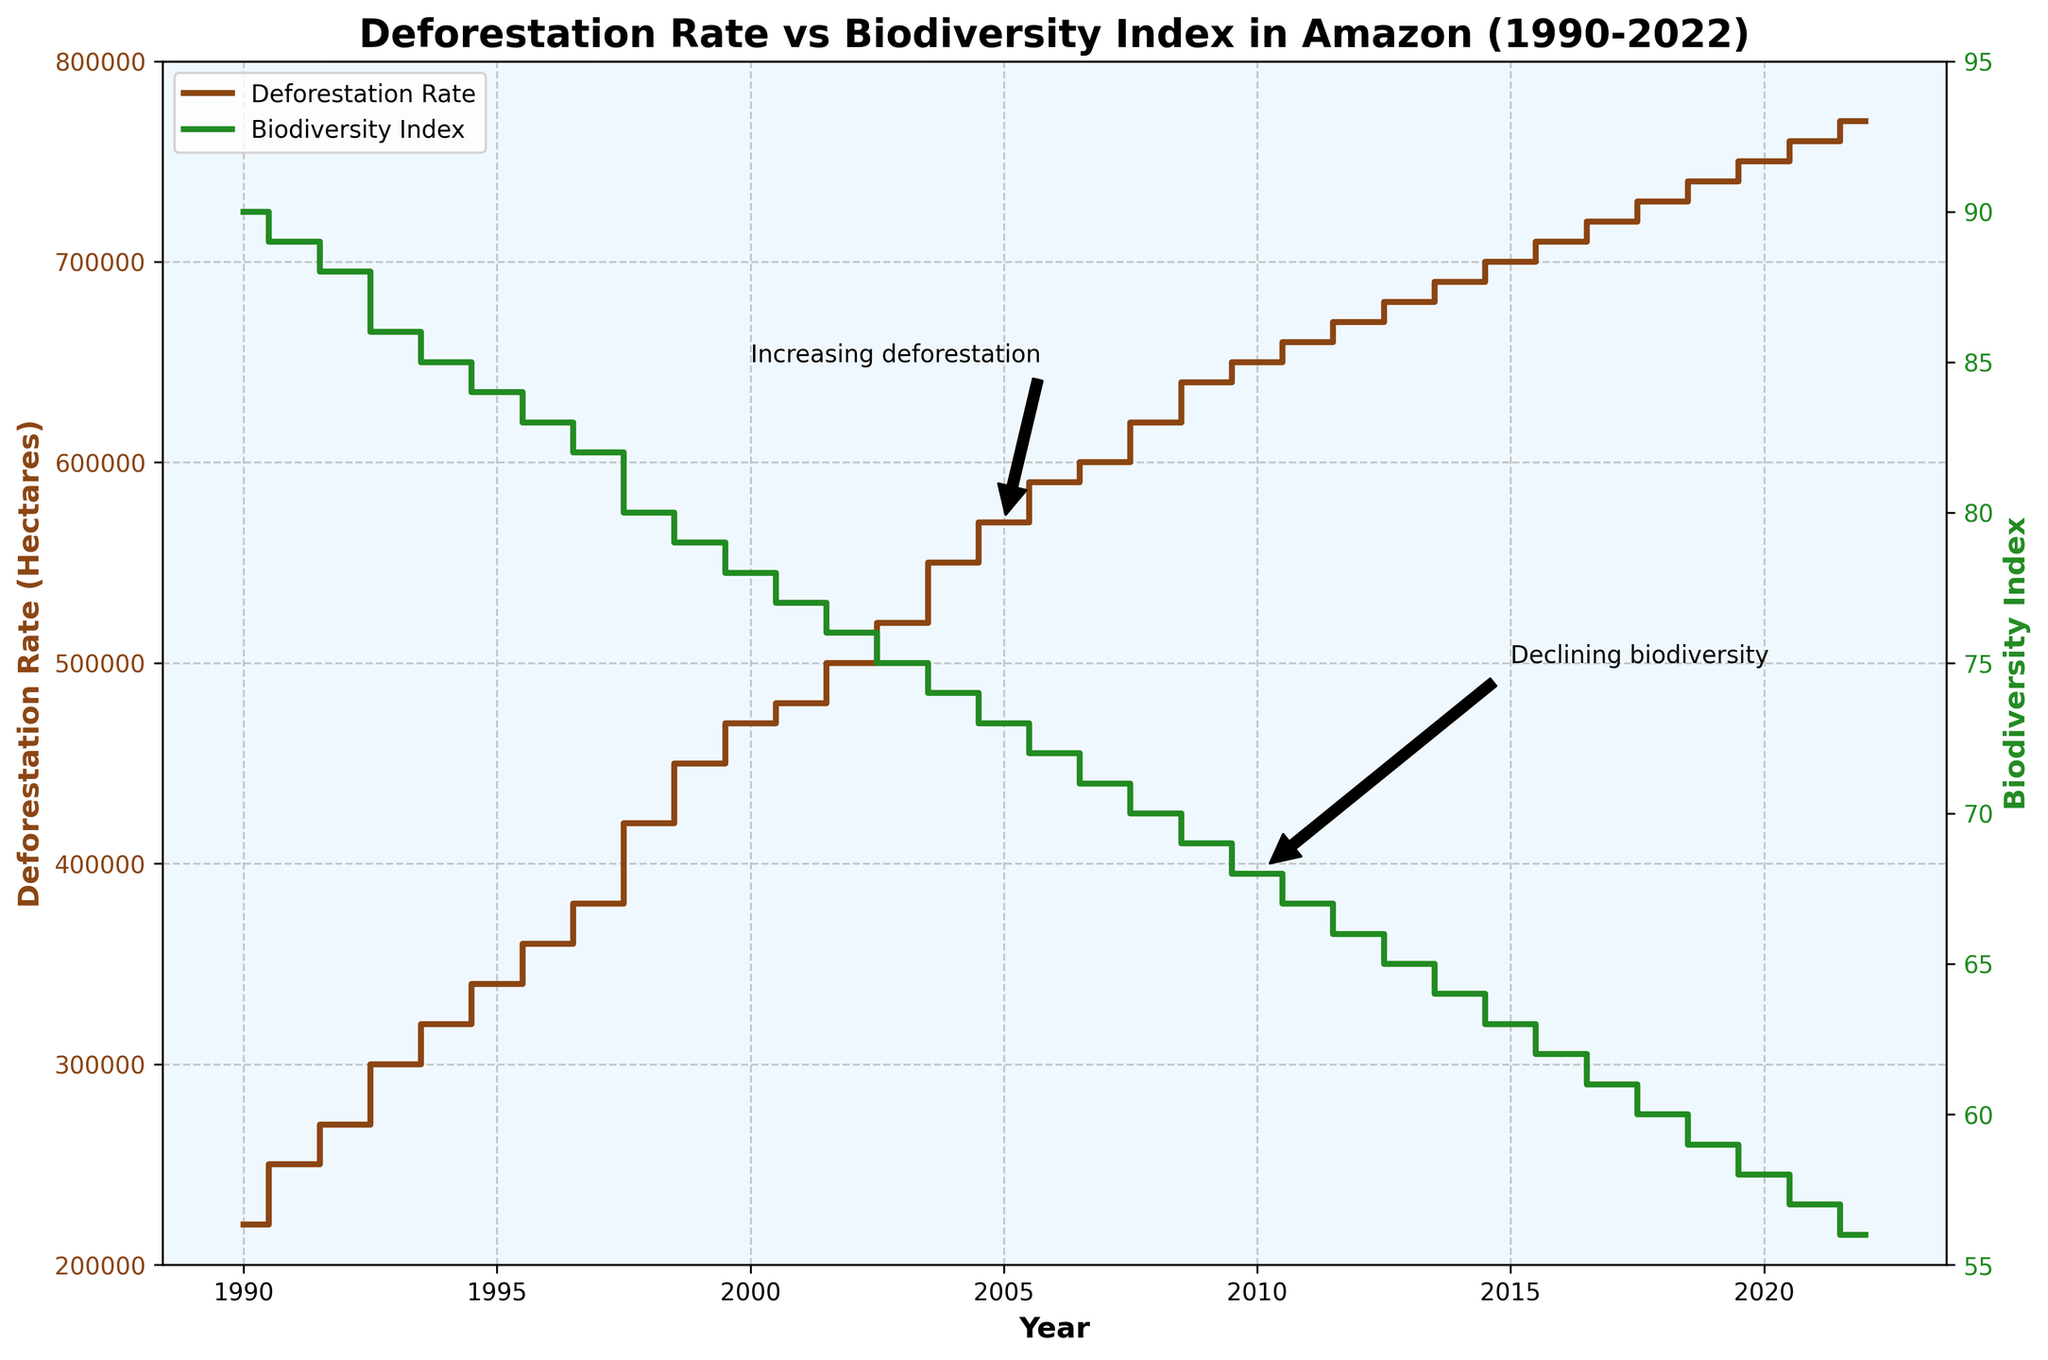what is the title of the figure? The title is displayed prominently at the top of the figure and provides a summary of what the plot represents.
Answer: Deforestation Rate vs Biodiversity Index in Amazon (1990-2022) How many years are covered in this plot? The x-axis represents the years from the beginning to the end of the dataset. Counting these will give us the total number of years included.
Answer: 33 What color represents the deforestation rate in the plot? Referring to the legend and the lines on the plot, we can identify the respective colors for deforestation rate and biodiversity index.
Answer: Brown By how much did the biodiversity index decrease from 1990 to 2022? Compare the biodiversity index values for the years 1990 and 2022. Subtract the 2022 value from the 1990 value to find the decrease.
Answer: 34 Which year marked the highest deforestation rate? Locate the highest point on the deforestation rate line on the plot and refer to the corresponding year on the x-axis.
Answer: 2022 How does the deforestation rate trend compare between 1995 and 2000? Observe the trend of the deforestation rate line between 1995 and 2000 to determine if it is increasing, decreasing, or remaining constant.
Answer: Increasing What relationship can be observed between deforestation rates and biodiversity index? Review the trends of the two lines (deforestation rate and biodiversity index) and analyze the nature of their relationship—whether they move together or inversely.
Answer: Inversely related How much did the deforestation rate increase from 1990 to 2005? Compare the deforestation rate values for the years 1990 and 2005. Subtract the 1990 value from the 2005 value to find the increase.
Answer: 350000 hectares Which period saw a steeper decline in biodiversity index: 1990-2000 or 2010-2020? Analyze the slope of the biodiversity index line during the periods 1990-2000 and 2010-2020. The steeper the slope, the greater the decline in biodiversity index.
Answer: 1990-2000 What annotation points out 'Increasing deforestation' and where is it located? Check the annotations on the plot to find which one mentions "Increasing deforestation" and note its location on the plot.
Answer: Near the year 2005, at a deforestation rate of 570000 hectares 